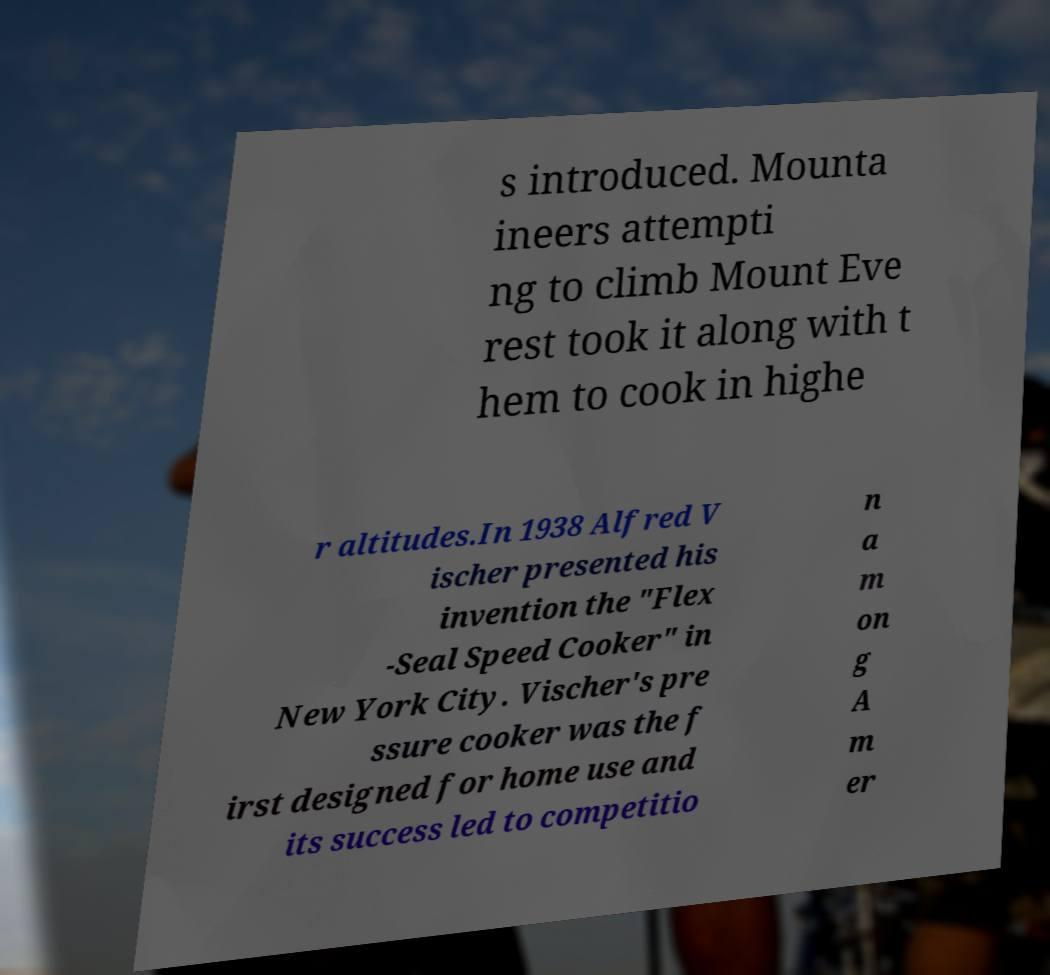I need the written content from this picture converted into text. Can you do that? s introduced. Mounta ineers attempti ng to climb Mount Eve rest took it along with t hem to cook in highe r altitudes.In 1938 Alfred V ischer presented his invention the "Flex -Seal Speed Cooker" in New York City. Vischer's pre ssure cooker was the f irst designed for home use and its success led to competitio n a m on g A m er 